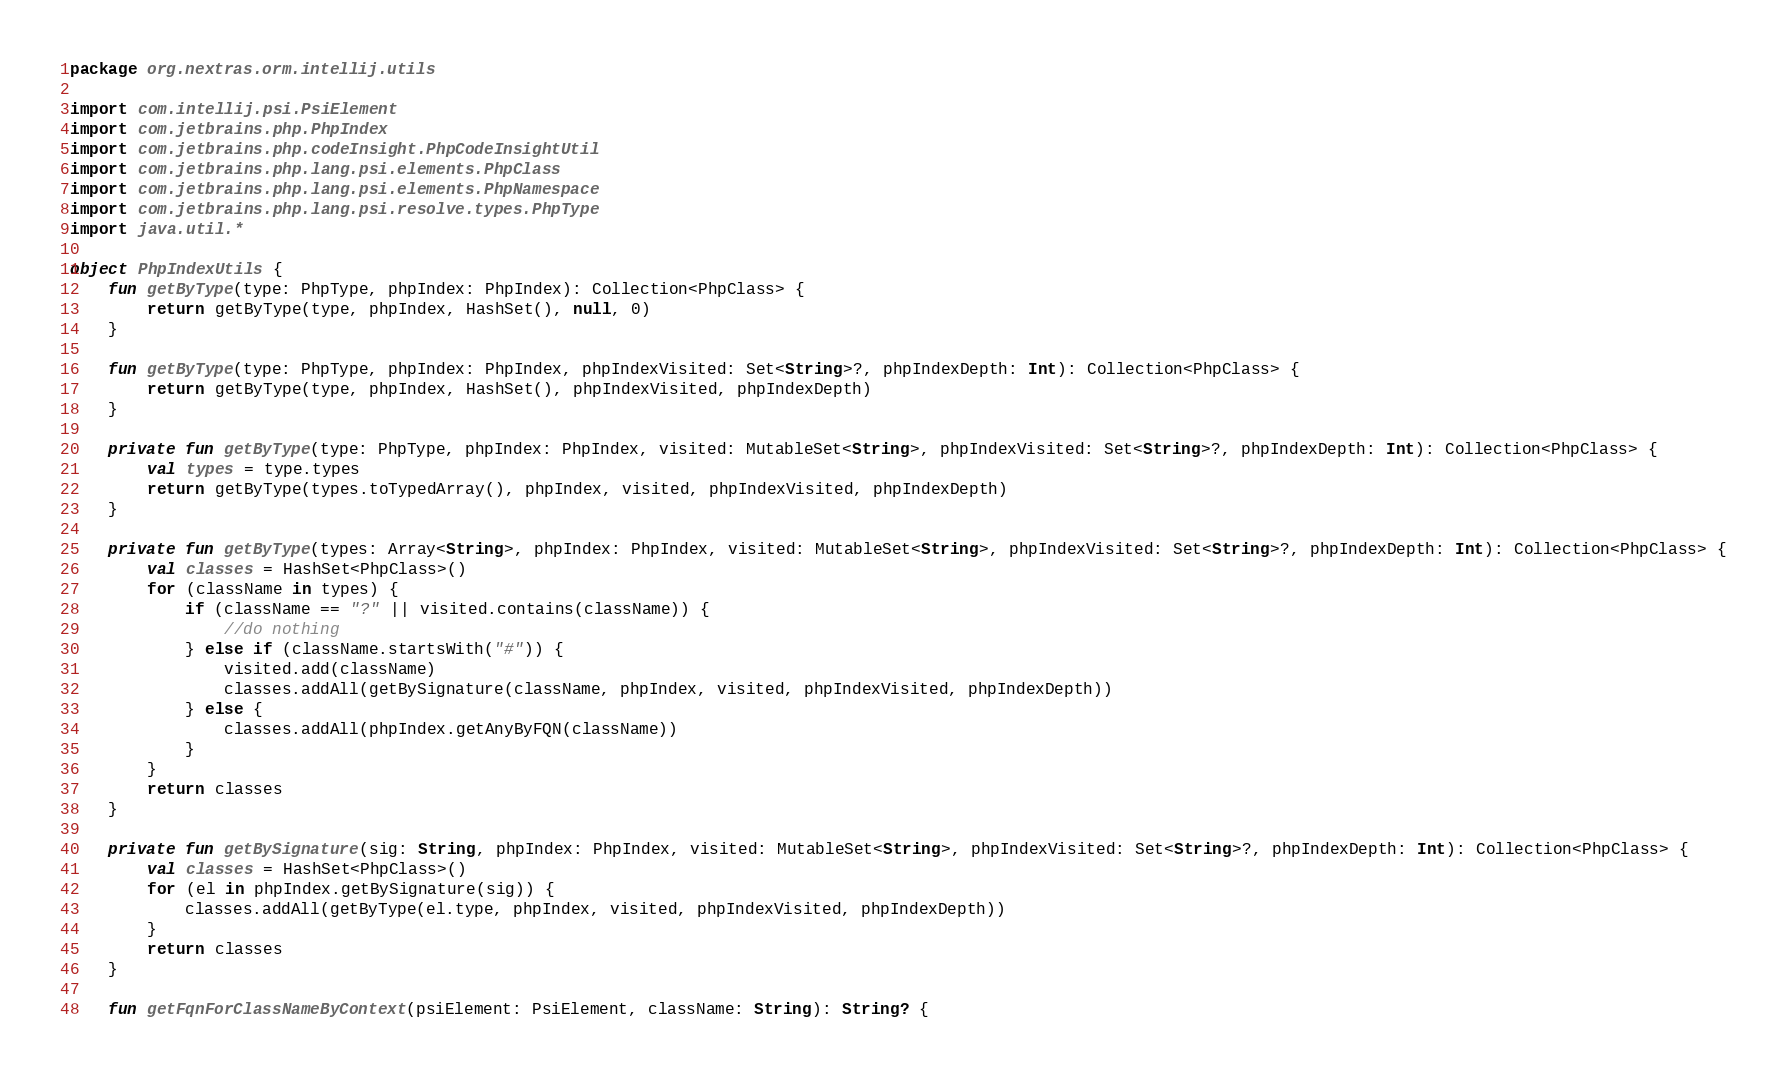<code> <loc_0><loc_0><loc_500><loc_500><_Kotlin_>package org.nextras.orm.intellij.utils

import com.intellij.psi.PsiElement
import com.jetbrains.php.PhpIndex
import com.jetbrains.php.codeInsight.PhpCodeInsightUtil
import com.jetbrains.php.lang.psi.elements.PhpClass
import com.jetbrains.php.lang.psi.elements.PhpNamespace
import com.jetbrains.php.lang.psi.resolve.types.PhpType
import java.util.*

object PhpIndexUtils {
	fun getByType(type: PhpType, phpIndex: PhpIndex): Collection<PhpClass> {
		return getByType(type, phpIndex, HashSet(), null, 0)
	}

	fun getByType(type: PhpType, phpIndex: PhpIndex, phpIndexVisited: Set<String>?, phpIndexDepth: Int): Collection<PhpClass> {
		return getByType(type, phpIndex, HashSet(), phpIndexVisited, phpIndexDepth)
	}

	private fun getByType(type: PhpType, phpIndex: PhpIndex, visited: MutableSet<String>, phpIndexVisited: Set<String>?, phpIndexDepth: Int): Collection<PhpClass> {
		val types = type.types
		return getByType(types.toTypedArray(), phpIndex, visited, phpIndexVisited, phpIndexDepth)
	}

	private fun getByType(types: Array<String>, phpIndex: PhpIndex, visited: MutableSet<String>, phpIndexVisited: Set<String>?, phpIndexDepth: Int): Collection<PhpClass> {
		val classes = HashSet<PhpClass>()
		for (className in types) {
			if (className == "?" || visited.contains(className)) {
				//do nothing
			} else if (className.startsWith("#")) {
				visited.add(className)
				classes.addAll(getBySignature(className, phpIndex, visited, phpIndexVisited, phpIndexDepth))
			} else {
				classes.addAll(phpIndex.getAnyByFQN(className))
			}
		}
		return classes
	}

	private fun getBySignature(sig: String, phpIndex: PhpIndex, visited: MutableSet<String>, phpIndexVisited: Set<String>?, phpIndexDepth: Int): Collection<PhpClass> {
		val classes = HashSet<PhpClass>()
		for (el in phpIndex.getBySignature(sig)) {
			classes.addAll(getByType(el.type, phpIndex, visited, phpIndexVisited, phpIndexDepth))
		}
		return classes
	}

	fun getFqnForClassNameByContext(psiElement: PsiElement, className: String): String? {</code> 